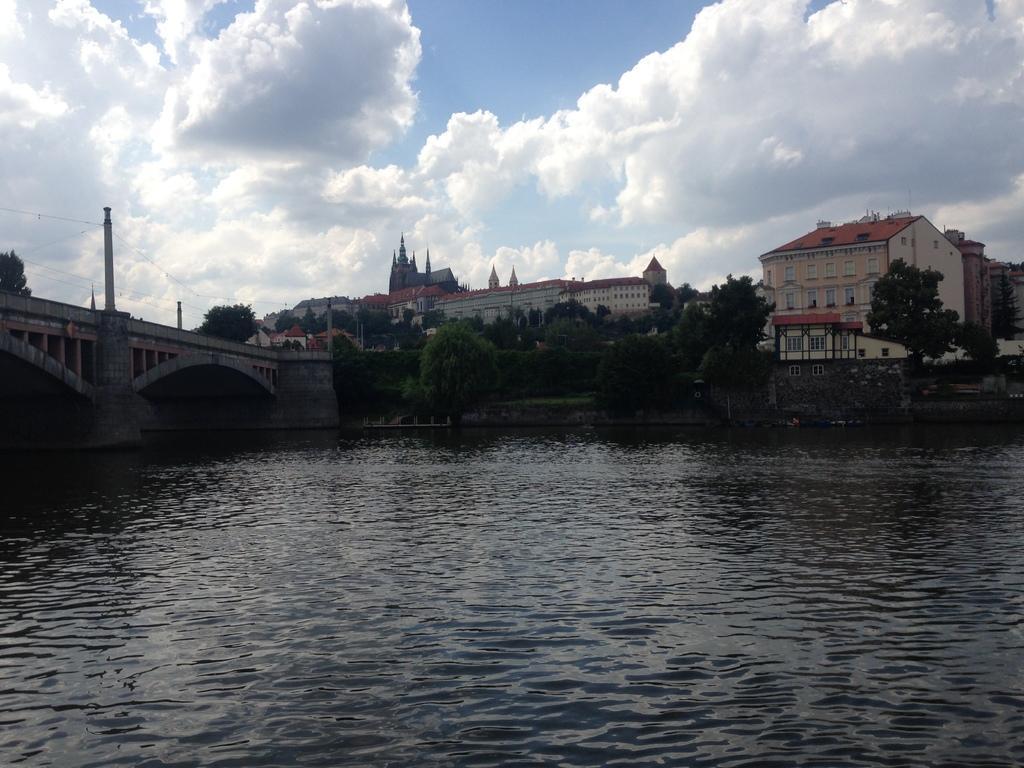Please provide a concise description of this image. In this image we can see there are buildings, bridge and wires attached to it. And there are trees, water and the cloudy sky. 